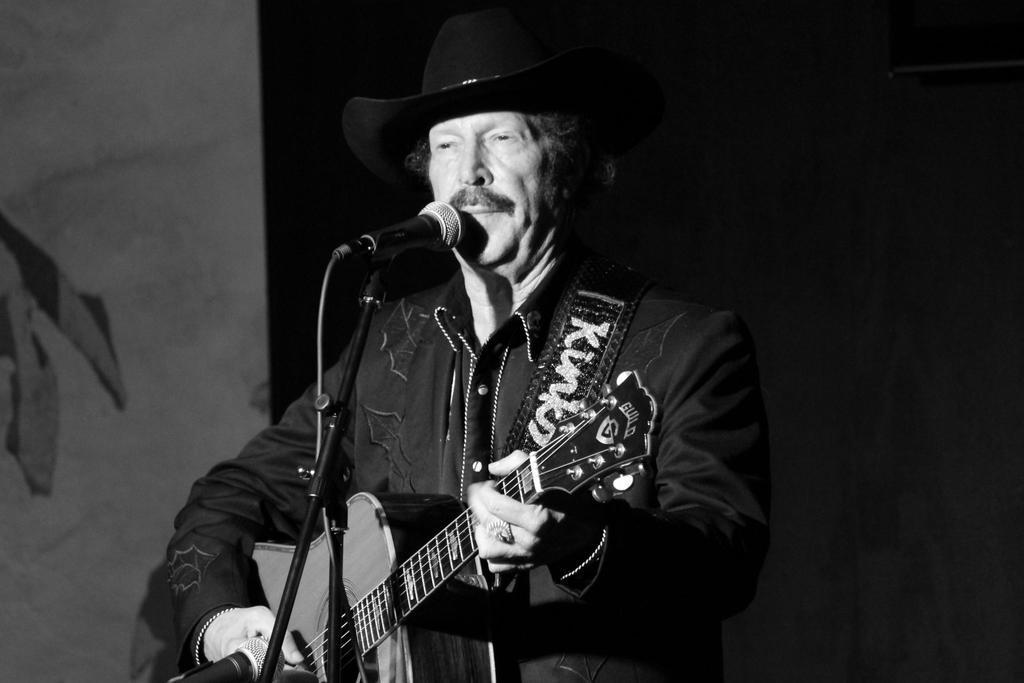How would you summarize this image in a sentence or two? This person standing and playing guitar and wear black color hat,in front of this person there is a ,microphone with stand. On the background we can see wall. 